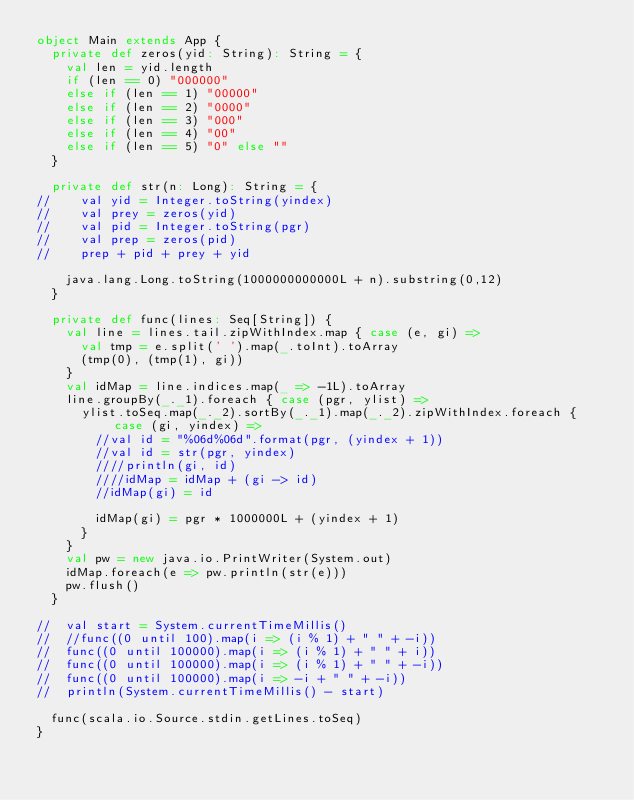<code> <loc_0><loc_0><loc_500><loc_500><_Scala_>object Main extends App {
	private def zeros(yid: String): String = {
		val len = yid.length
		if (len == 0) "000000"
		else if (len == 1) "00000"
		else if (len == 2) "0000"
		else if (len == 3) "000"
		else if (len == 4) "00"
		else if (len == 5) "0" else ""
	}

	private def str(n: Long): String = {
//		val yid = Integer.toString(yindex)
//		val prey = zeros(yid)
//		val pid = Integer.toString(pgr)
//		val prep = zeros(pid)
//		prep + pid + prey + yid

		java.lang.Long.toString(1000000000000L + n).substring(0,12)
	}

	private def func(lines: Seq[String]) {
		val line = lines.tail.zipWithIndex.map { case (e, gi) =>
			val tmp = e.split(' ').map(_.toInt).toArray
			(tmp(0), (tmp(1), gi))
		}
		val idMap = line.indices.map(_ => -1L).toArray
		line.groupBy(_._1).foreach { case (pgr, ylist) =>
			ylist.toSeq.map(_._2).sortBy(_._1).map(_._2).zipWithIndex.foreach { case (gi, yindex) =>
				//val id = "%06d%06d".format(pgr, (yindex + 1))
				//val id = str(pgr, yindex)
				////println(gi, id)
				////idMap = idMap + (gi -> id)
				//idMap(gi) = id

				idMap(gi) = pgr * 1000000L + (yindex + 1)
			}
		}
		val pw = new java.io.PrintWriter(System.out)
		idMap.foreach(e => pw.println(str(e)))
		pw.flush()
	}

//	val start = System.currentTimeMillis()
//	//func((0 until 100).map(i => (i % 1) + " " + -i))
//	func((0 until 100000).map(i => (i % 1) + " " + i))
//	func((0 until 100000).map(i => (i % 1) + " " + -i))
//	func((0 until 100000).map(i => -i + " " + -i))
//	println(System.currentTimeMillis() - start)

	func(scala.io.Source.stdin.getLines.toSeq)
}
</code> 